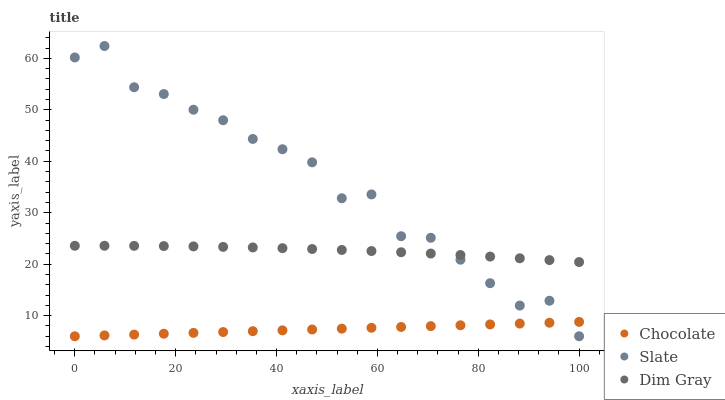Does Chocolate have the minimum area under the curve?
Answer yes or no. Yes. Does Slate have the maximum area under the curve?
Answer yes or no. Yes. Does Dim Gray have the minimum area under the curve?
Answer yes or no. No. Does Dim Gray have the maximum area under the curve?
Answer yes or no. No. Is Chocolate the smoothest?
Answer yes or no. Yes. Is Slate the roughest?
Answer yes or no. Yes. Is Dim Gray the smoothest?
Answer yes or no. No. Is Dim Gray the roughest?
Answer yes or no. No. Does Slate have the lowest value?
Answer yes or no. Yes. Does Dim Gray have the lowest value?
Answer yes or no. No. Does Slate have the highest value?
Answer yes or no. Yes. Does Dim Gray have the highest value?
Answer yes or no. No. Is Chocolate less than Dim Gray?
Answer yes or no. Yes. Is Dim Gray greater than Chocolate?
Answer yes or no. Yes. Does Slate intersect Dim Gray?
Answer yes or no. Yes. Is Slate less than Dim Gray?
Answer yes or no. No. Is Slate greater than Dim Gray?
Answer yes or no. No. Does Chocolate intersect Dim Gray?
Answer yes or no. No. 